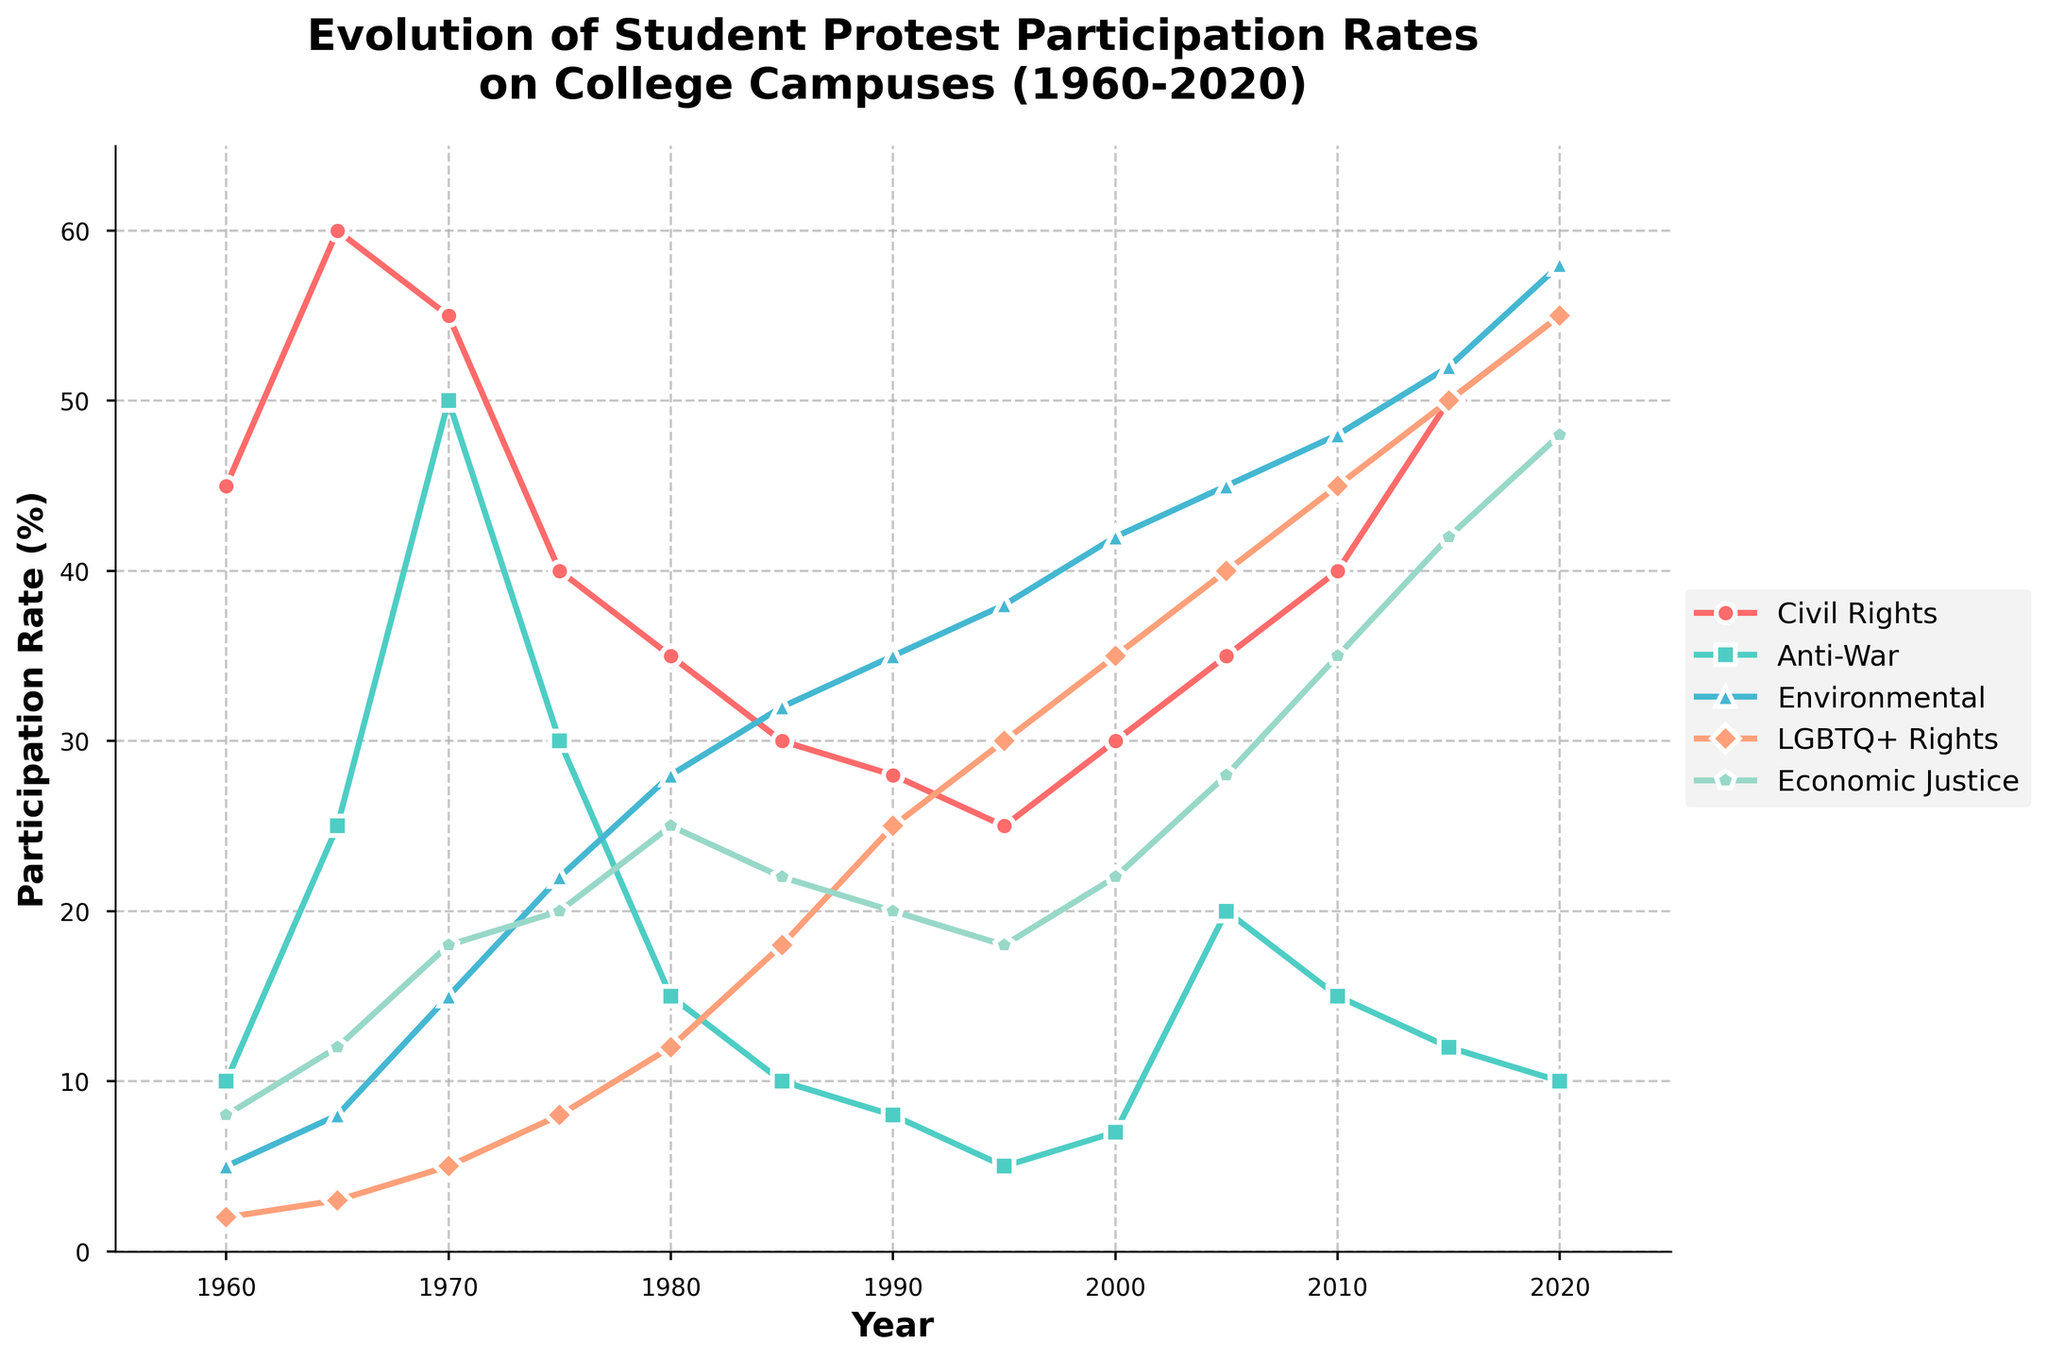What year did student protests for Civil Rights and Environmental causes have an equal participation rate? To find when the participation rates for Civil Rights and Environmental causes were equal, observe the intersection points of the two lines on the chart. The Civil Rights and Environmental cause lines cross at the year 1965.
Answer: 1965 Which cause saw the largest increase in participation rate between 2000 and 2020? Calculate the difference in participation rate from 2000 to 2020 for each cause. Civil Rights increased from 30 to 55 (Δ=25), Anti-War from 7 to 10 (Δ=3), Environmental from 42 to 58 (Δ=16), LGBTQ+ Rights from 35 to 55 (Δ=20), Economic Justice from 22 to 48 (Δ=26). Economic Justice has the largest increase.
Answer: Economic Justice Which cause consistently increased in student protest participation from 1960 to 2020 without any decline? Scan each line on the chart from 1960 to 2020. The Environmental line steadily increases in participation rate without any declines.
Answer: Environmental How many causes had a participation rate higher than 50% in 2020? Review the chart at the year 2020. The participation rates are Civil Rights (55), Environmental (58), LGBTQ+ Rights (55), and Economic Justice (48). Only Civil Rights, Environmental, and LGBTQ+ Rights are above 50%.
Answer: 3 In what decade did student protests for LGBTQ+ Rights surpass those for Anti-War causes? Observe the changing relative heights of the lines for LGBTQ+ Rights and Anti-War over the decades. LGBTQ+ Rights surpass Anti-War between 1985 and 1990.
Answer: 1980s Which cause had the highest participation rate in 1980, and what was it? Check the heights of the lines at the year 1980. The highest belongs to Economic Justice with a rate of 25%.
Answer: Economic Justice, 25% What is the average participation rate of Civil Rights protests over the 60 years? Add all participation rates for Civil Rights from 1960 to 2020, and divide by the number of data points (12). (45 + 60 + 55 + 40 + 35 + 30 + 28 + 25 + 30 + 35 + 40 + 50 + 55) / 12 = 42.5
Answer: 42.5 Compare the highest participation rates for Economic Justice and Anti-War causes. Which is higher and by how much? Find the highest points in the Economic Justice and Anti-War lines. Economic Justice peaks at 48% in 2020, and Anti-War peaks at 50% in 1970. The difference is 50 - 48 = 2.
Answer: Anti-War, by 2% In what decade did student protests for Civil Rights see their largest drop in participation rate? Look at the Civil Rights line for the steepest downward slope. The largest drop occurs between 1965 (60%) and 1975 (40%), a 20% drop in one decade.
Answer: 1970s 